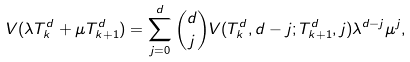<formula> <loc_0><loc_0><loc_500><loc_500>V ( \lambda T _ { k } ^ { d } + \mu T _ { k + 1 } ^ { d } ) = \sum _ { j = 0 } ^ { d } \binom { d } { j } V ( T _ { k } ^ { d } , d - j ; T _ { k + 1 } ^ { d } , j ) \lambda ^ { d - j } \mu ^ { j } ,</formula> 